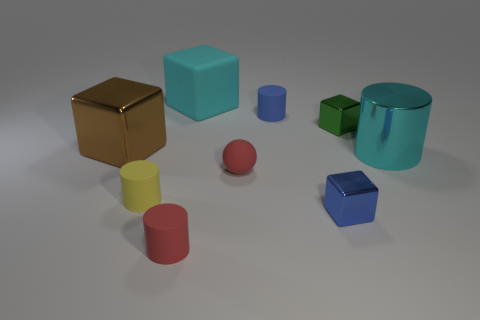The metallic cylinder that is the same color as the matte block is what size?
Your answer should be compact. Large. What color is the small metal cube behind the block that is in front of the large metallic object to the right of the green object?
Your answer should be very brief. Green. How many other things are the same shape as the big brown shiny thing?
Make the answer very short. 3. Is there a yellow cylinder behind the red rubber object on the right side of the big rubber block?
Provide a short and direct response. No. What number of rubber things are either green objects or cylinders?
Provide a succinct answer. 3. What is the material of the object that is to the right of the brown metallic cube and to the left of the tiny red cylinder?
Provide a succinct answer. Rubber. Are there any green cubes that are to the left of the small shiny cube that is behind the big cyan thing on the right side of the tiny ball?
Ensure brevity in your answer.  No. Are there any other things that are made of the same material as the yellow object?
Provide a succinct answer. Yes. There is a large cyan thing that is made of the same material as the small blue cube; what shape is it?
Provide a short and direct response. Cylinder. Is the number of brown shiny objects that are in front of the large cyan cylinder less than the number of tiny red cylinders behind the big metal block?
Provide a short and direct response. No. 